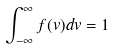<formula> <loc_0><loc_0><loc_500><loc_500>\int _ { - \infty } ^ { \infty } f ( v ) d v = 1</formula> 